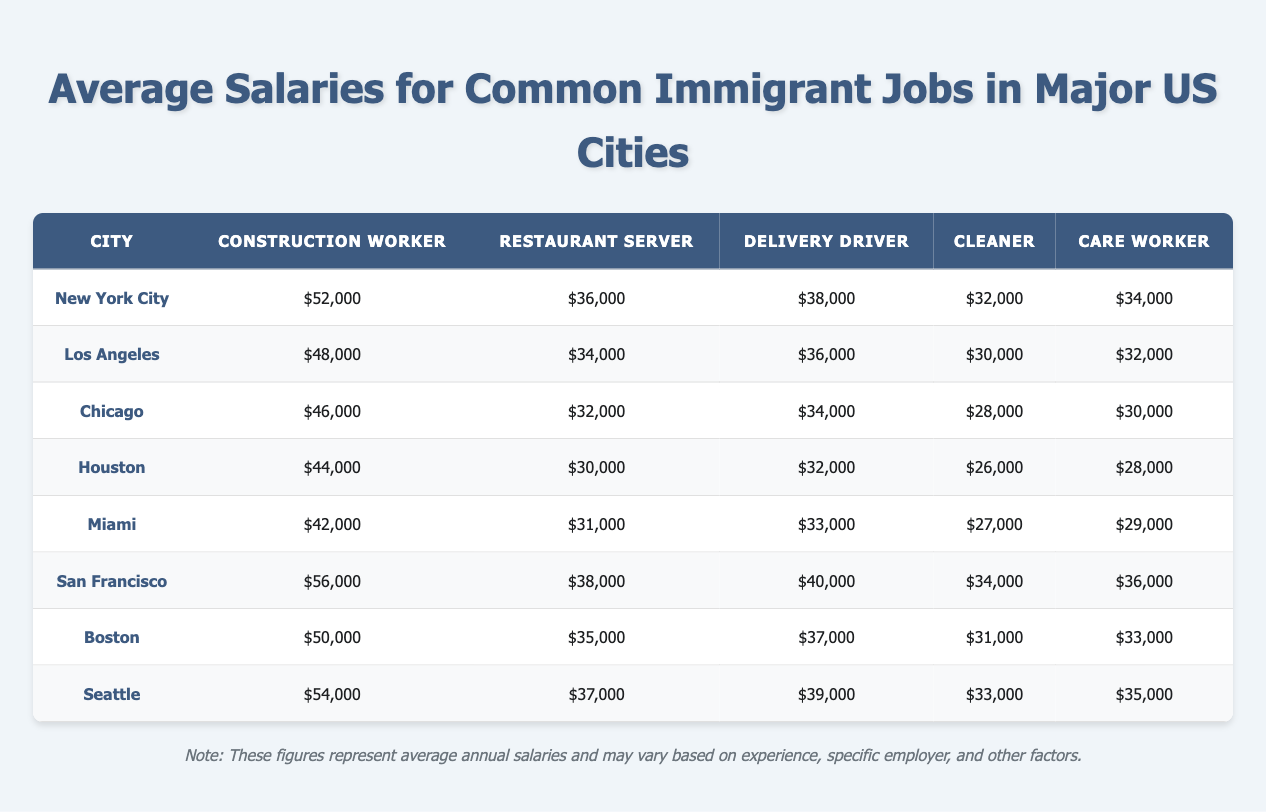What is the average salary for a Construction Worker in New York City? According to the table, the average salary for a Construction Worker in New York City is $52,000.
Answer: $52,000 Which city has the highest salary for a Restaurant Server? By examining the table, San Francisco has the highest salary for a Restaurant Server at $38,000.
Answer: San Francisco Is the salary for a Cleaner in Miami higher than in Houston? Miami has a salary of $27,000 for a Cleaner, while Houston's salary for the same job is $26,000. Since $27,000 is greater than $26,000, the statement is true.
Answer: Yes What is the difference between the highest and lowest average salary for Delivery Drivers across the cities listed? The highest average salary for Delivery Drivers is in San Francisco at $40,000, and the lowest is in Houston at $32,000. The difference is calculated as $40,000 - $32,000 = $8,000.
Answer: $8,000 In which city can a Care Worker earn $34,000? Looking at the table, a Care Worker can earn $34,000 in New York City.
Answer: New York City What is the average salary for a Delivery Driver in Seattle and Boston combined? In Seattle, the average salary for a Delivery Driver is $39,000, and in Boston, it is $37,000. To find the combined average, we add the two salaries: $39,000 + $37,000 = $76,000, and then divide by 2 to get the average: $76,000 / 2 = $38,000.
Answer: $38,000 Is the average salary for a Care Worker in Chicago higher than $30,000? The salary for a Care Worker in Chicago is $30,000, which means it is not higher than $30,000; it is equal. Therefore, the answer is false.
Answer: No In which city does a Construction Worker earn the least? By looking at the table, a Construction Worker earns the least in Houston with a salary of $44,000 compared to the other cities listed.
Answer: Houston What is the average salary for Restaurant Servers across all the cities? To find the average salary for Restaurant Servers, we sum the salaries: $36,000 + $34,000 + $32,000 + $30,000 + $31,000 + $38,000 + $35,000 + $37,000 = $303,000. There are 8 cities, so the average is $303,000 / 8 = $37,875.
Answer: $37,875 